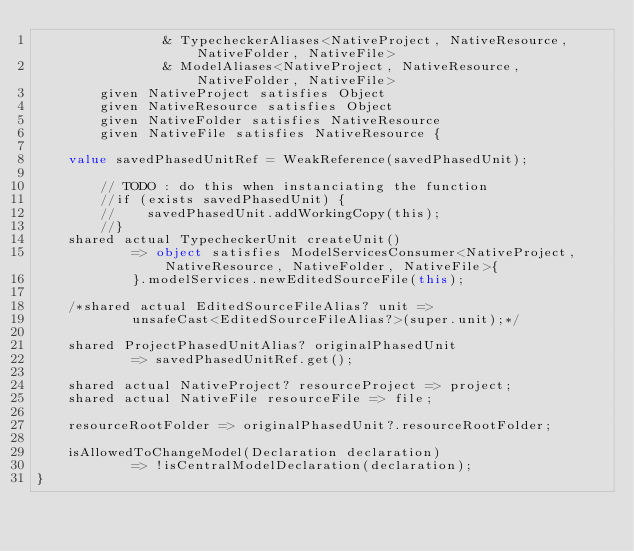Convert code to text. <code><loc_0><loc_0><loc_500><loc_500><_Ceylon_>                & TypecheckerAliases<NativeProject, NativeResource, NativeFolder, NativeFile>
                & ModelAliases<NativeProject, NativeResource, NativeFolder, NativeFile>
        given NativeProject satisfies Object
        given NativeResource satisfies Object
        given NativeFolder satisfies NativeResource
        given NativeFile satisfies NativeResource {
    
    value savedPhasedUnitRef = WeakReference(savedPhasedUnit);

        // TODO : do this when instanciating the function
        //if (exists savedPhasedUnit) {
        //    savedPhasedUnit.addWorkingCopy(this);
        //}
    shared actual TypecheckerUnit createUnit() 
            => object satisfies ModelServicesConsumer<NativeProject, NativeResource, NativeFolder, NativeFile>{
            }.modelServices.newEditedSourceFile(this);
    
    /*shared actual EditedSourceFileAlias? unit =>
            unsafeCast<EditedSourceFileAlias?>(super.unit);*/

    shared ProjectPhasedUnitAlias? originalPhasedUnit 
            => savedPhasedUnitRef.get();
    
    shared actual NativeProject? resourceProject => project;
    shared actual NativeFile resourceFile => file;
    
    resourceRootFolder => originalPhasedUnit?.resourceRootFolder;
    
    isAllowedToChangeModel(Declaration declaration) 
            => !isCentralModelDeclaration(declaration);
}





</code> 